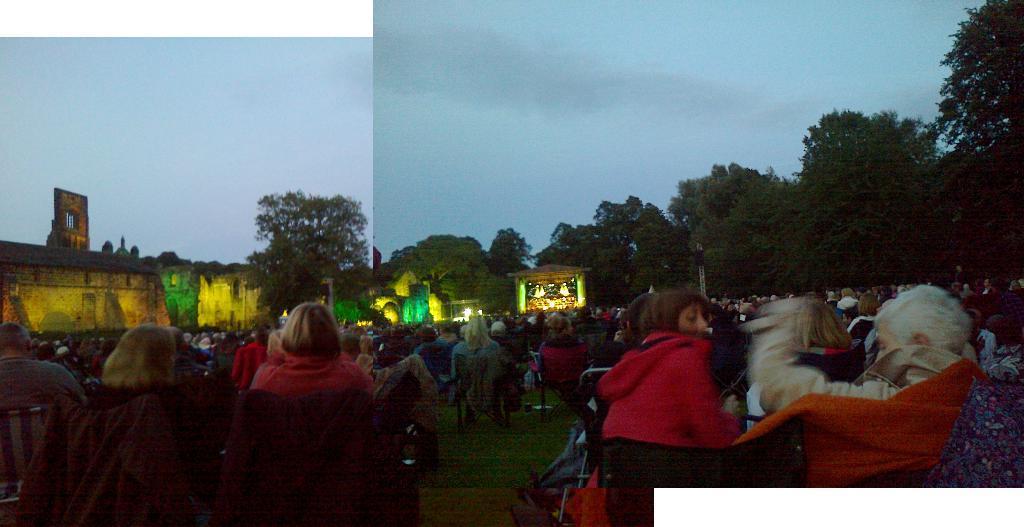Could you give a brief overview of what you see in this image? In this picture we can see group of people, they are sitting on the chairs, in the background we can see few trees, buildings and lights. 